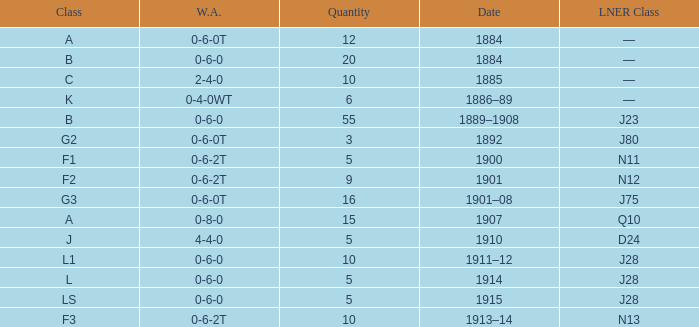What WA has a LNER Class of n13 and 10? 0-6-2T. 